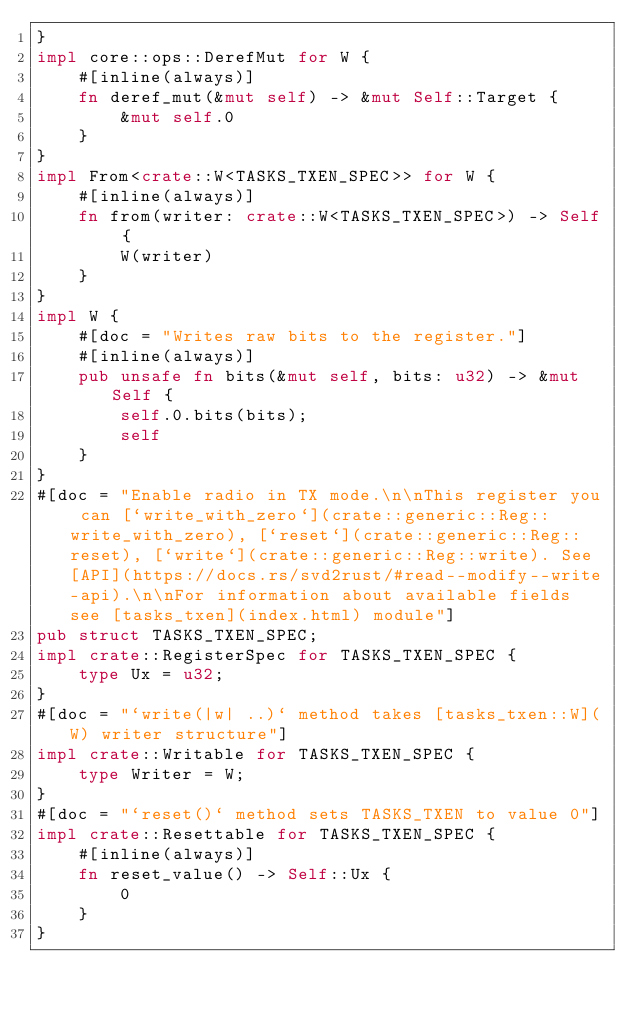Convert code to text. <code><loc_0><loc_0><loc_500><loc_500><_Rust_>}
impl core::ops::DerefMut for W {
    #[inline(always)]
    fn deref_mut(&mut self) -> &mut Self::Target {
        &mut self.0
    }
}
impl From<crate::W<TASKS_TXEN_SPEC>> for W {
    #[inline(always)]
    fn from(writer: crate::W<TASKS_TXEN_SPEC>) -> Self {
        W(writer)
    }
}
impl W {
    #[doc = "Writes raw bits to the register."]
    #[inline(always)]
    pub unsafe fn bits(&mut self, bits: u32) -> &mut Self {
        self.0.bits(bits);
        self
    }
}
#[doc = "Enable radio in TX mode.\n\nThis register you can [`write_with_zero`](crate::generic::Reg::write_with_zero), [`reset`](crate::generic::Reg::reset), [`write`](crate::generic::Reg::write). See [API](https://docs.rs/svd2rust/#read--modify--write-api).\n\nFor information about available fields see [tasks_txen](index.html) module"]
pub struct TASKS_TXEN_SPEC;
impl crate::RegisterSpec for TASKS_TXEN_SPEC {
    type Ux = u32;
}
#[doc = "`write(|w| ..)` method takes [tasks_txen::W](W) writer structure"]
impl crate::Writable for TASKS_TXEN_SPEC {
    type Writer = W;
}
#[doc = "`reset()` method sets TASKS_TXEN to value 0"]
impl crate::Resettable for TASKS_TXEN_SPEC {
    #[inline(always)]
    fn reset_value() -> Self::Ux {
        0
    }
}
</code> 